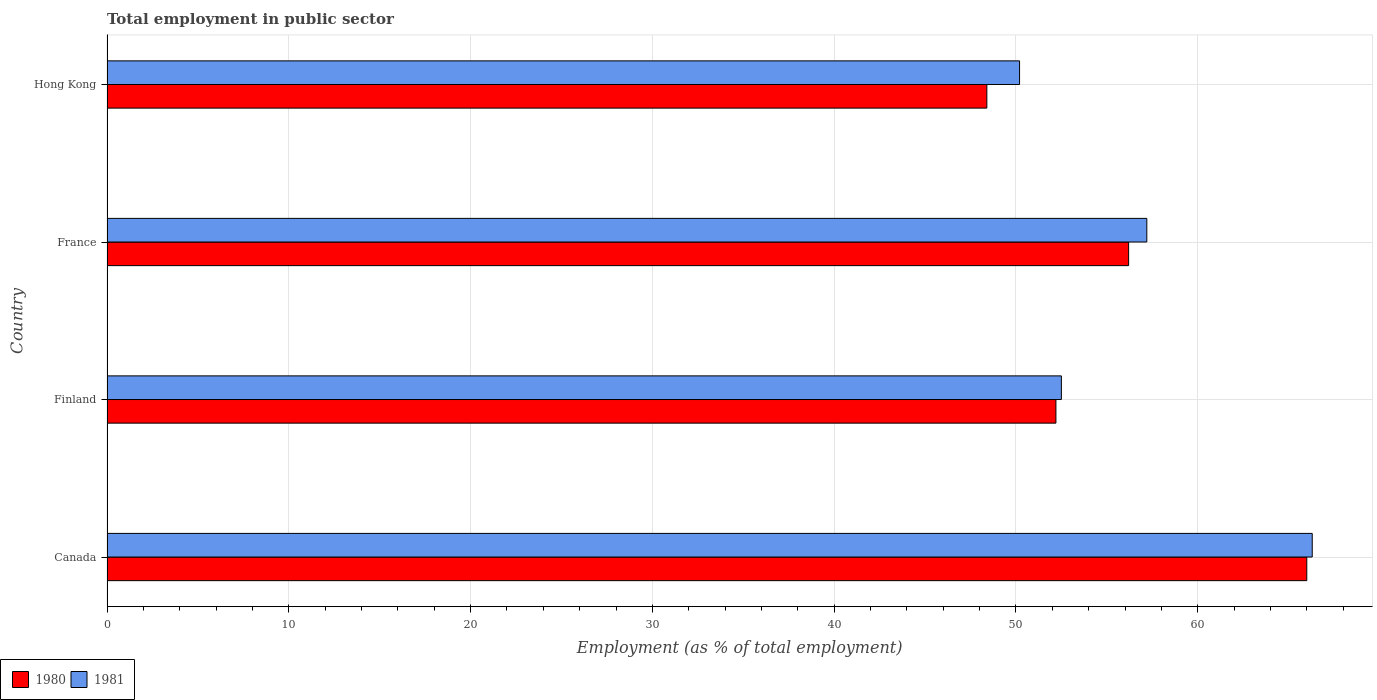Are the number of bars per tick equal to the number of legend labels?
Your answer should be compact. Yes. Are the number of bars on each tick of the Y-axis equal?
Offer a very short reply. Yes. What is the label of the 3rd group of bars from the top?
Make the answer very short. Finland. What is the employment in public sector in 1981 in Hong Kong?
Offer a terse response. 50.2. Across all countries, what is the maximum employment in public sector in 1981?
Make the answer very short. 66.3. Across all countries, what is the minimum employment in public sector in 1980?
Your response must be concise. 48.4. In which country was the employment in public sector in 1980 minimum?
Offer a terse response. Hong Kong. What is the total employment in public sector in 1981 in the graph?
Your answer should be compact. 226.2. What is the difference between the employment in public sector in 1981 in Canada and that in Finland?
Give a very brief answer. 13.8. What is the average employment in public sector in 1981 per country?
Ensure brevity in your answer.  56.55. What is the difference between the employment in public sector in 1980 and employment in public sector in 1981 in Hong Kong?
Keep it short and to the point. -1.8. In how many countries, is the employment in public sector in 1981 greater than 12 %?
Offer a terse response. 4. What is the ratio of the employment in public sector in 1980 in France to that in Hong Kong?
Offer a very short reply. 1.16. What is the difference between the highest and the second highest employment in public sector in 1980?
Your response must be concise. 9.8. What is the difference between the highest and the lowest employment in public sector in 1980?
Your answer should be very brief. 17.6. In how many countries, is the employment in public sector in 1980 greater than the average employment in public sector in 1980 taken over all countries?
Your response must be concise. 2. How many bars are there?
Your response must be concise. 8. Are the values on the major ticks of X-axis written in scientific E-notation?
Provide a short and direct response. No. Does the graph contain grids?
Ensure brevity in your answer.  Yes. What is the title of the graph?
Offer a terse response. Total employment in public sector. What is the label or title of the X-axis?
Give a very brief answer. Employment (as % of total employment). What is the Employment (as % of total employment) in 1980 in Canada?
Give a very brief answer. 66. What is the Employment (as % of total employment) in 1981 in Canada?
Provide a succinct answer. 66.3. What is the Employment (as % of total employment) in 1980 in Finland?
Offer a terse response. 52.2. What is the Employment (as % of total employment) in 1981 in Finland?
Your answer should be compact. 52.5. What is the Employment (as % of total employment) in 1980 in France?
Your answer should be very brief. 56.2. What is the Employment (as % of total employment) of 1981 in France?
Your answer should be compact. 57.2. What is the Employment (as % of total employment) of 1980 in Hong Kong?
Your answer should be compact. 48.4. What is the Employment (as % of total employment) of 1981 in Hong Kong?
Your answer should be very brief. 50.2. Across all countries, what is the maximum Employment (as % of total employment) in 1980?
Provide a short and direct response. 66. Across all countries, what is the maximum Employment (as % of total employment) in 1981?
Provide a short and direct response. 66.3. Across all countries, what is the minimum Employment (as % of total employment) of 1980?
Offer a very short reply. 48.4. Across all countries, what is the minimum Employment (as % of total employment) in 1981?
Provide a short and direct response. 50.2. What is the total Employment (as % of total employment) of 1980 in the graph?
Offer a very short reply. 222.8. What is the total Employment (as % of total employment) of 1981 in the graph?
Provide a short and direct response. 226.2. What is the difference between the Employment (as % of total employment) of 1980 in Canada and that in Finland?
Give a very brief answer. 13.8. What is the difference between the Employment (as % of total employment) of 1981 in Canada and that in Finland?
Make the answer very short. 13.8. What is the difference between the Employment (as % of total employment) in 1980 in Canada and that in France?
Provide a short and direct response. 9.8. What is the difference between the Employment (as % of total employment) of 1981 in Canada and that in France?
Ensure brevity in your answer.  9.1. What is the difference between the Employment (as % of total employment) of 1981 in Canada and that in Hong Kong?
Ensure brevity in your answer.  16.1. What is the difference between the Employment (as % of total employment) of 1981 in Finland and that in France?
Make the answer very short. -4.7. What is the difference between the Employment (as % of total employment) in 1981 in Finland and that in Hong Kong?
Offer a terse response. 2.3. What is the difference between the Employment (as % of total employment) of 1981 in France and that in Hong Kong?
Offer a very short reply. 7. What is the difference between the Employment (as % of total employment) of 1980 in Canada and the Employment (as % of total employment) of 1981 in Finland?
Make the answer very short. 13.5. What is the difference between the Employment (as % of total employment) of 1980 in Finland and the Employment (as % of total employment) of 1981 in France?
Your answer should be very brief. -5. What is the difference between the Employment (as % of total employment) of 1980 in Finland and the Employment (as % of total employment) of 1981 in Hong Kong?
Offer a very short reply. 2. What is the average Employment (as % of total employment) in 1980 per country?
Offer a very short reply. 55.7. What is the average Employment (as % of total employment) in 1981 per country?
Your answer should be very brief. 56.55. What is the difference between the Employment (as % of total employment) of 1980 and Employment (as % of total employment) of 1981 in Finland?
Offer a very short reply. -0.3. What is the ratio of the Employment (as % of total employment) in 1980 in Canada to that in Finland?
Your answer should be compact. 1.26. What is the ratio of the Employment (as % of total employment) of 1981 in Canada to that in Finland?
Make the answer very short. 1.26. What is the ratio of the Employment (as % of total employment) of 1980 in Canada to that in France?
Provide a succinct answer. 1.17. What is the ratio of the Employment (as % of total employment) in 1981 in Canada to that in France?
Your response must be concise. 1.16. What is the ratio of the Employment (as % of total employment) of 1980 in Canada to that in Hong Kong?
Provide a short and direct response. 1.36. What is the ratio of the Employment (as % of total employment) of 1981 in Canada to that in Hong Kong?
Provide a short and direct response. 1.32. What is the ratio of the Employment (as % of total employment) in 1980 in Finland to that in France?
Ensure brevity in your answer.  0.93. What is the ratio of the Employment (as % of total employment) of 1981 in Finland to that in France?
Provide a succinct answer. 0.92. What is the ratio of the Employment (as % of total employment) of 1980 in Finland to that in Hong Kong?
Give a very brief answer. 1.08. What is the ratio of the Employment (as % of total employment) in 1981 in Finland to that in Hong Kong?
Give a very brief answer. 1.05. What is the ratio of the Employment (as % of total employment) in 1980 in France to that in Hong Kong?
Keep it short and to the point. 1.16. What is the ratio of the Employment (as % of total employment) in 1981 in France to that in Hong Kong?
Make the answer very short. 1.14. What is the difference between the highest and the second highest Employment (as % of total employment) in 1980?
Ensure brevity in your answer.  9.8. What is the difference between the highest and the second highest Employment (as % of total employment) in 1981?
Keep it short and to the point. 9.1. What is the difference between the highest and the lowest Employment (as % of total employment) of 1980?
Your response must be concise. 17.6. 